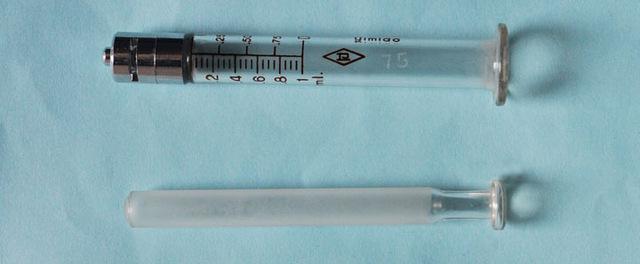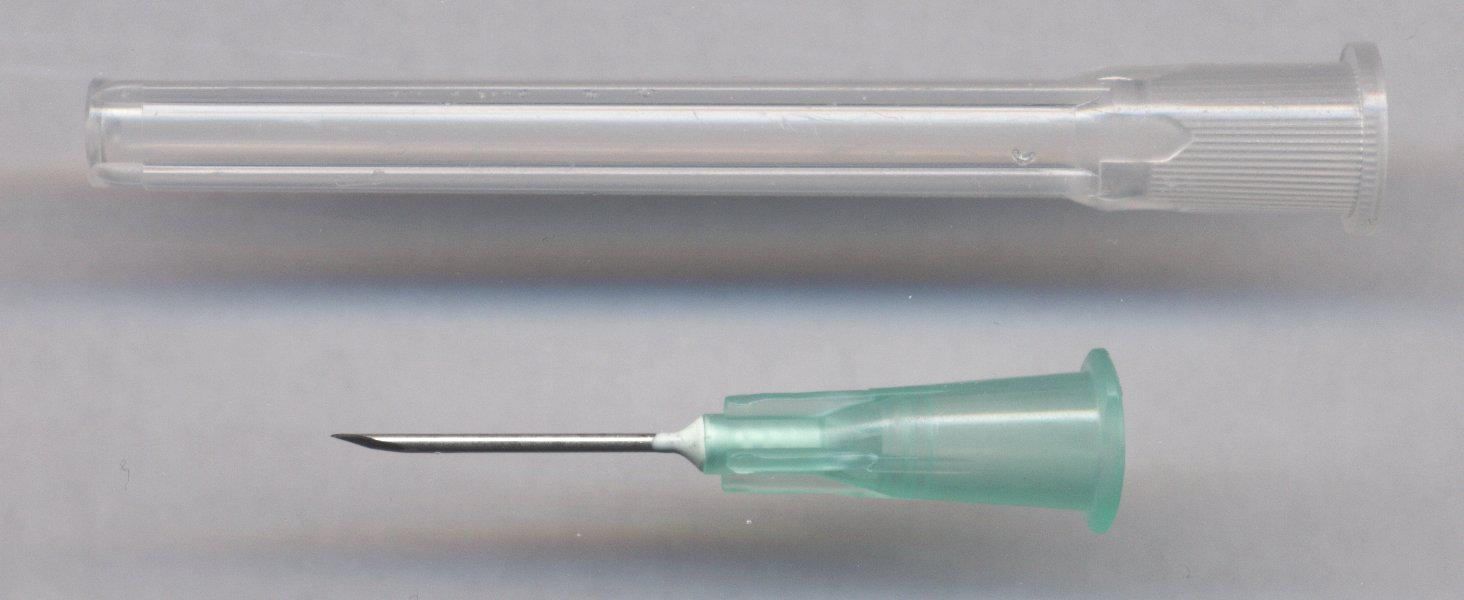The first image is the image on the left, the second image is the image on the right. For the images shown, is this caption "There is exactly one syringe in the right image." true? Answer yes or no. No. 